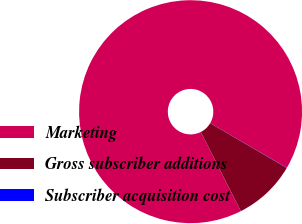Convert chart to OTSL. <chart><loc_0><loc_0><loc_500><loc_500><pie_chart><fcel>Marketing<fcel>Gross subscriber additions<fcel>Subscriber acquisition cost<nl><fcel>90.85%<fcel>9.12%<fcel>0.03%<nl></chart> 